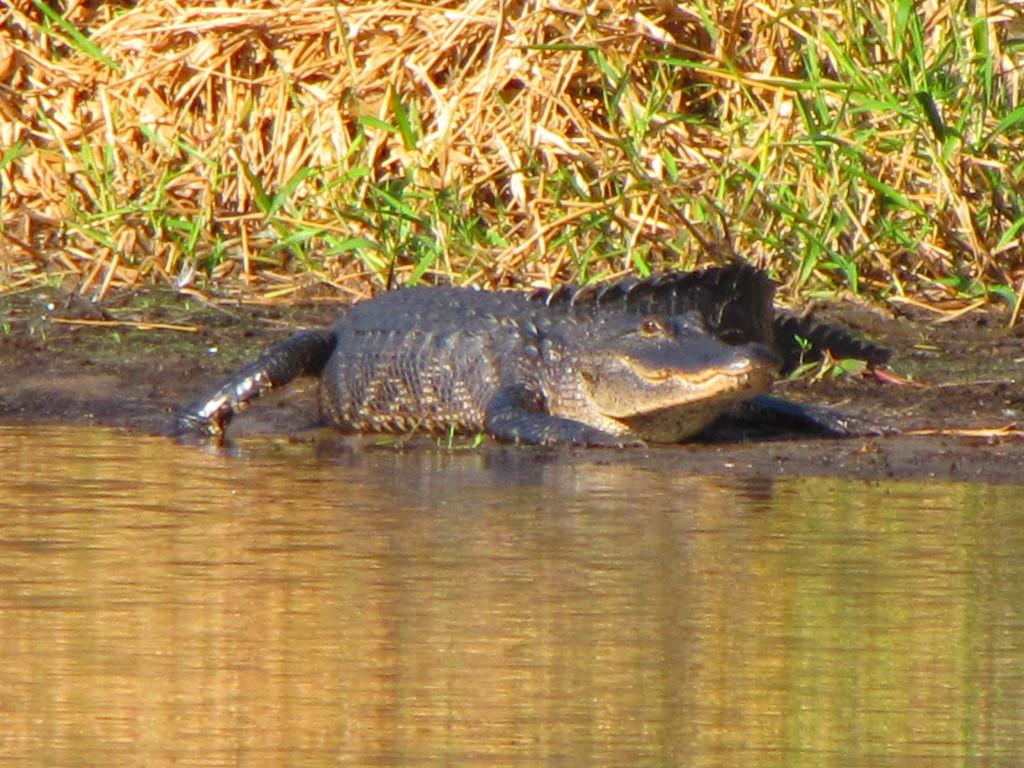What is the primary element visible in the image? There is water in the image. What type of animal can be seen on the ground in the image? There is a crocodile on the ground in the image. What can be seen in the background of the image? There are plants in the background of the image. How many dolls are playing with the trucks in the image? There are no dolls or trucks present in the image. What type of boys can be seen interacting with the crocodile in the image? There are no boys present in the image; it only features a crocodile and water. 